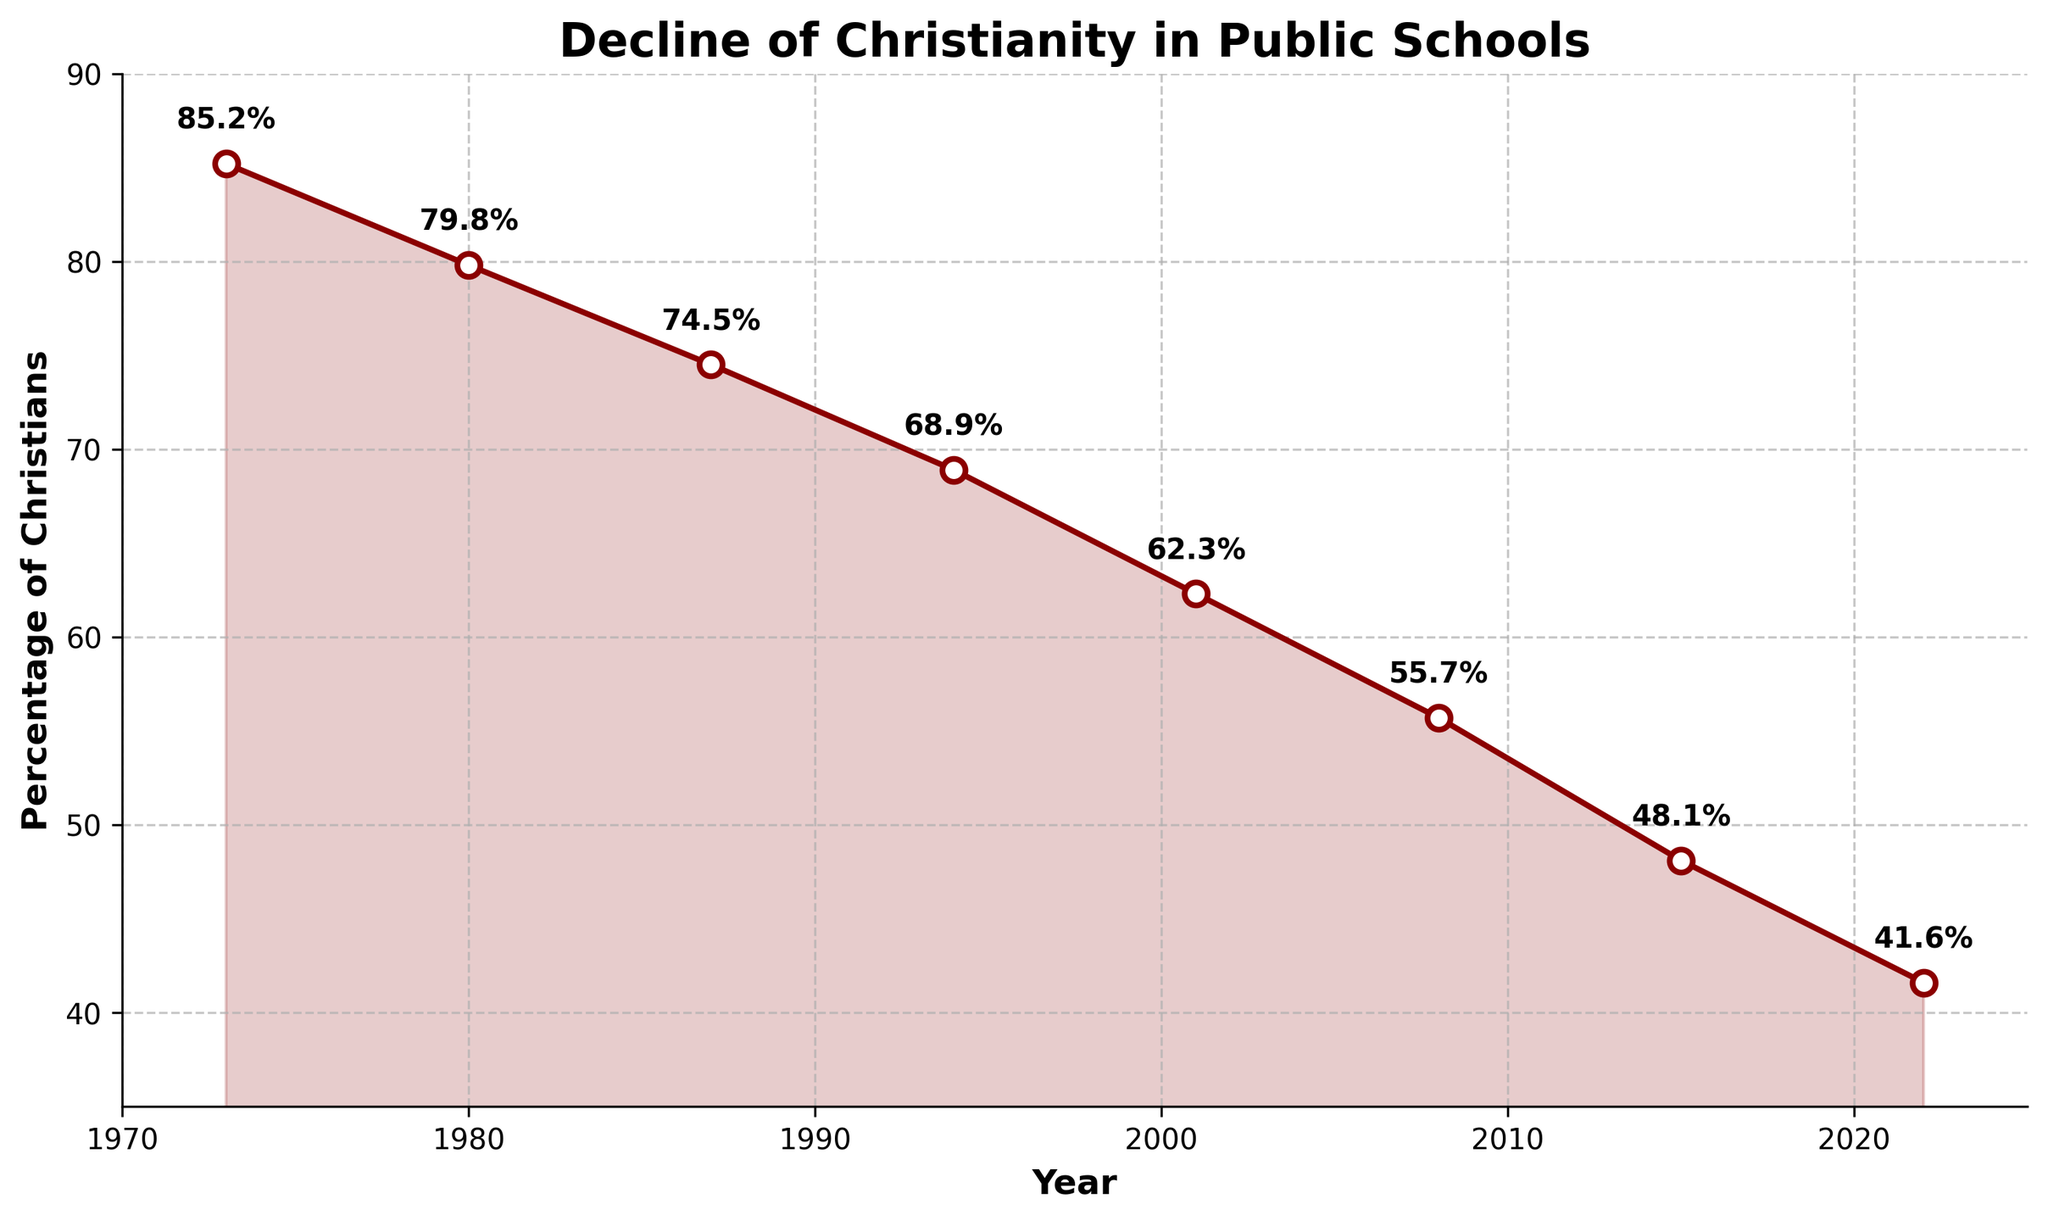Which year had the highest percentage of self-identified Christians in public schools? The highest percentage is represented by the point at the top of the chart which is in the year 1973.
Answer: 1973 What is the percentage decrease from 1973 to 2022? To find the decrease, subtract the 2022 percentage from the 1973 percentage: 85.2% - 41.6% = 43.6%.
Answer: 43.6% In which year was the drop in the percentage of self-identified Christians the largest compared to the previous period? Compare the percentage drops between each consecutive year and identify which one is the largest. The biggest drop occurred between 2001 and 2008 with a decrease from 62.3% to 55.7%, which is a drop of 6.6%.
Answer: 2001-2008 What is the average percentage of self-identified Christians over the past 50 years? Add all the percentages together and divide by the number of data points: (85.2 + 79.8 + 74.5 + 68.9 + 62.3 + 55.7 + 48.1 + 41.6) / 8 = 64.0%.
Answer: 64.0% Between which consecutive years did the percentage of self-identified Christians drop by approximately 6 percentage points? Examine drops between consecutive years, and we see between 1973 (85.2%) and 1980 (79.8%) the drop is (85.2% - 79.8% = 5.4%, which is approximate to 6).
Answer: 1973-1980 How many years saw a percentage decrease greater than 6 percentage points? Look for intervals where the drop is more than 6 points: 1980-1987, 1994-2001, and 2001-2008.
Answer: 3 Compare the percentage of self-identified Christians in 1987 and 2015. Which year had a higher percentage? Refer to the chart data to find the percentages for these years: 1987 had 74.5% and 2015 had 48.1%. 1987 has the higher percentage.
Answer: 1987 What is the percentage difference between the highest and lowest points on the chart? Calculate the difference between the highest point (85.2% in 1973) and the lowest (41.6% in 2022): 85.2% - 41.6% = 43.6%.
Answer: 43.6% If the trend continues, what might the percentage be in 2029? Use the rate of change from the last interval (2015 to 2022): (41.6 - 48.1) / (2022 - 2015) = -6.5/7 = -0.93 per year. Extrapolate for 2029 by continuing this rate: 41.6 + (7 * -0.93) = 41.6 - 6.51 ≈ 35.1%.
Answer: 35.1% Based on the visual slope, is the decline in percentage steeper in the first or second half of the timeline? Visually inspect the decline rate between 1973-1994 and 1994-2022. The latter half appears steeper given the cumulative percentage drop.
Answer: Second half 